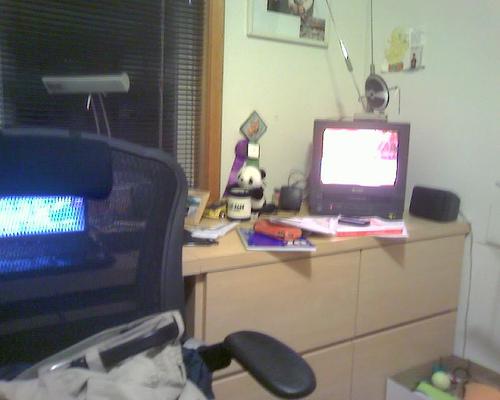Why are we able to see through the chair back?
Be succinct. Mesh. What type of gaming controller is on the desk?
Be succinct. Wii. Is the TV on?
Quick response, please. Yes. Are the computers in a cubicle?
Concise answer only. No. Is that a 3D television?
Give a very brief answer. No. 